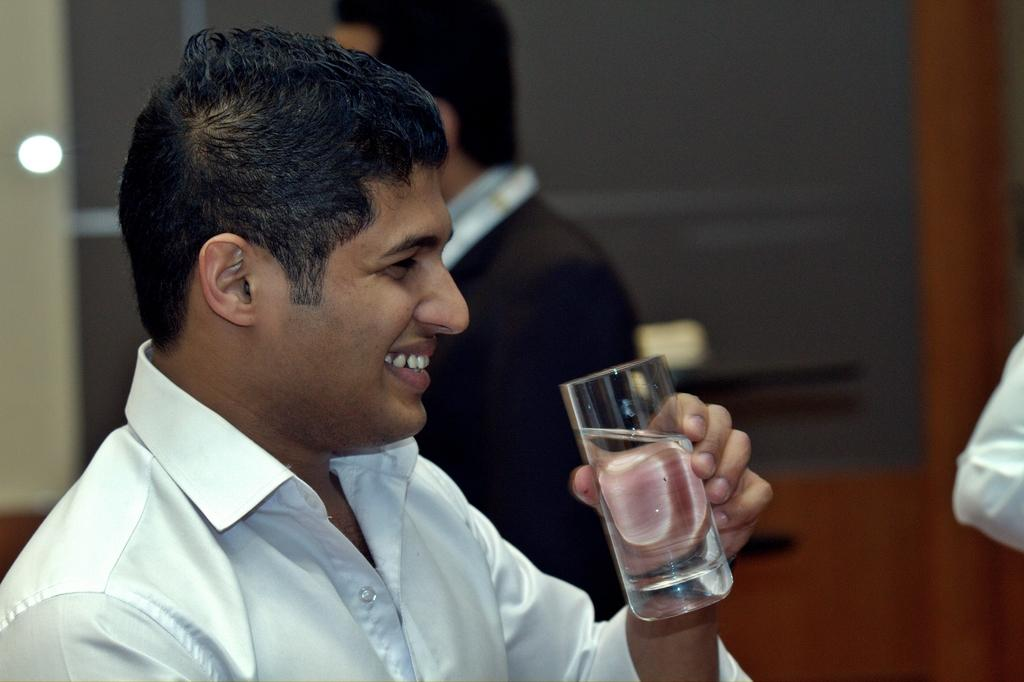How many people are in the image? There are people in the image. What is the man in the front holding in his hand? The man in the front is holding a glass in his hand. Can you describe the background of the image? The background of the image is blurred. What is the name of the actor in the image? There is no actor present in the image, and therefore no name can be provided. 